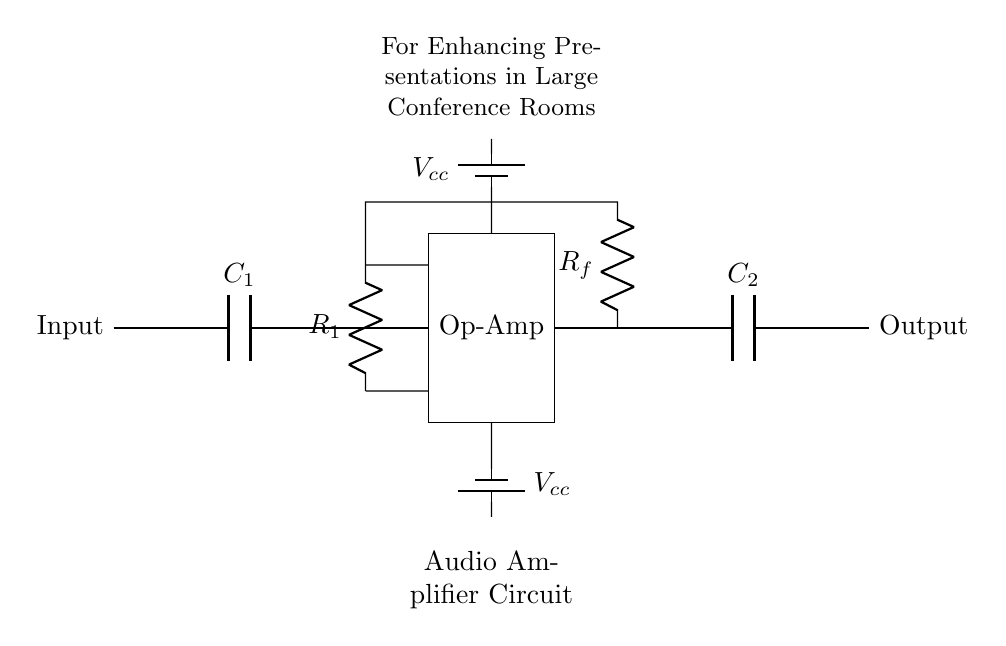What is the purpose of C1 in this circuit? C1 acts as a coupling capacitor that allows AC signals to pass while blocking DC components, ensuring that the input signal is properly processed by the amplifier.
Answer: Coupling capacitor What type of amplifier is represented in this circuit? The circuit represents an operational amplifier setup, as indicated by the labeled "Op-Amp" component, which is commonly used for various amplification tasks.
Answer: Operational amplifier What is the value associated with Rf? Rf represents the feedback resistor in this circuit, which affects the gain of the amplifier, but the specific value is not provided directly in the diagram.
Answer: Not specified What is supplied by Vcc in this circuit? Vcc supplies the necessary operating voltage for the op-amp, facilitating its function to amplify the input signal effectively.
Answer: Operating voltage How is the output taken from the circuit? The output is taken from the point after the capacitor C2, which filters the amplified signal and connects to the output node that indicates where the enhanced signal is available.
Answer: After C2 How many resistors are present in this circuit? There are two resistors visible in the circuit, one being R1 and the other being Rf, both of which play crucial roles in the amplification process.
Answer: Two resistors What does the rectangle labeled "Op-Amp" represent in this circuit? The rectangle labeled "Op-Amp" denotes the operational amplifier itself, an essential component that processes and amplifies the input signal based on its configuration and feedback mechanism.
Answer: Operational amplifier 